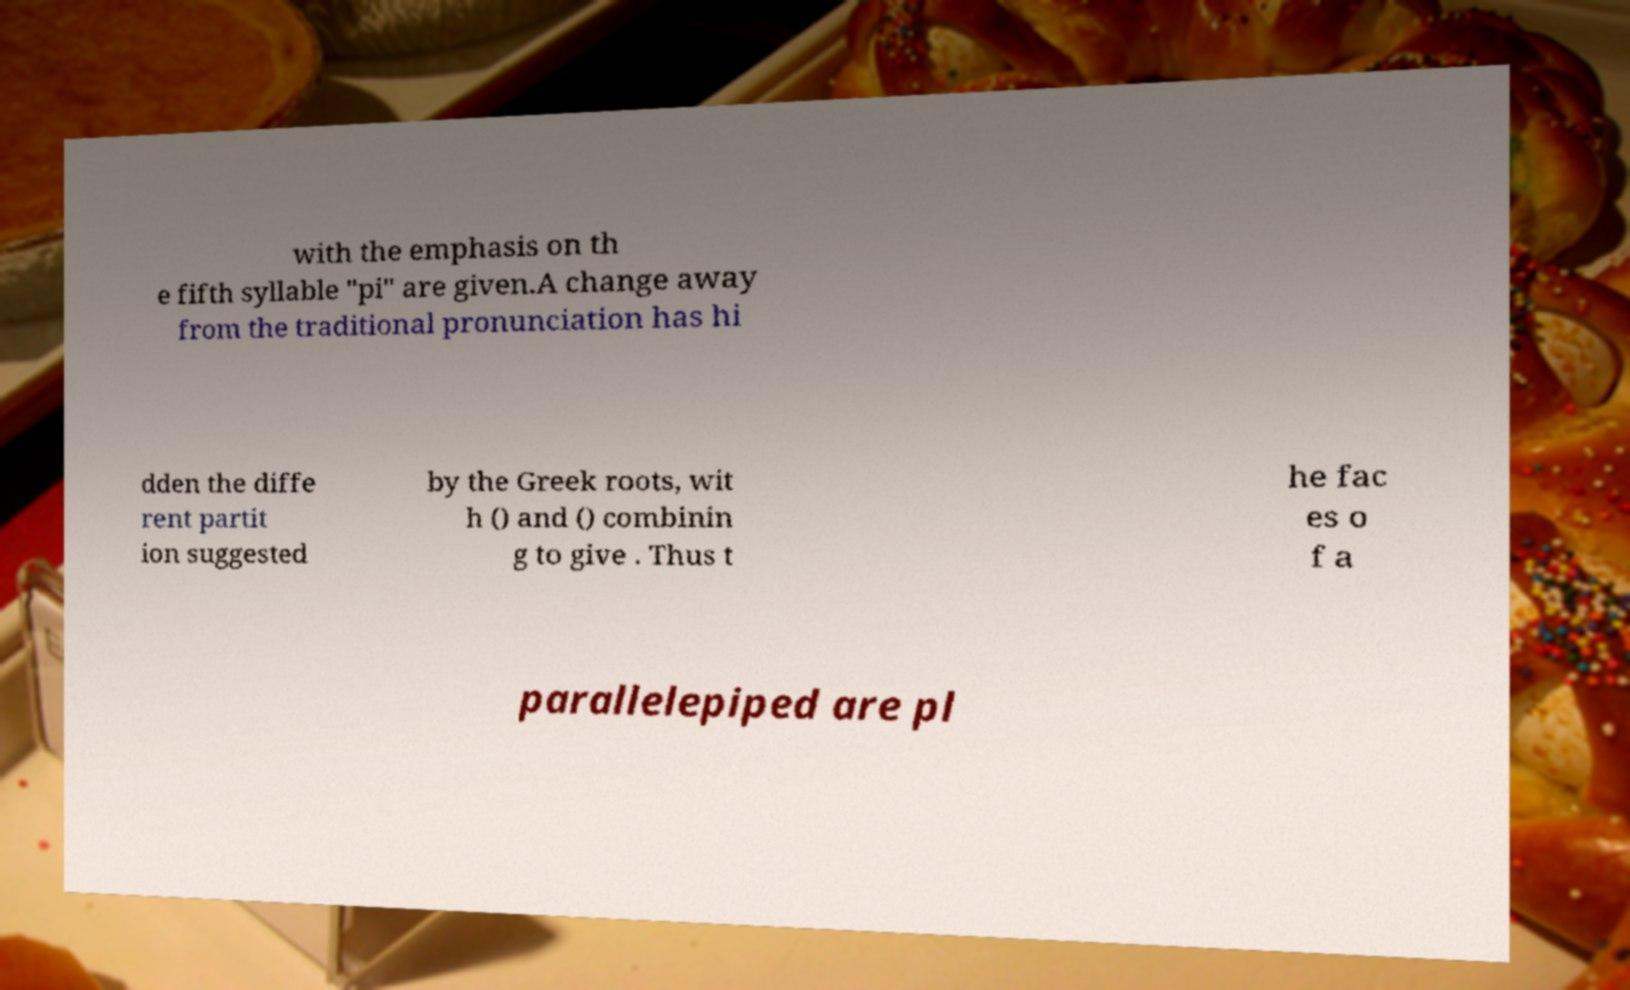Please read and relay the text visible in this image. What does it say? with the emphasis on th e fifth syllable "pi" are given.A change away from the traditional pronunciation has hi dden the diffe rent partit ion suggested by the Greek roots, wit h () and () combinin g to give . Thus t he fac es o f a parallelepiped are pl 